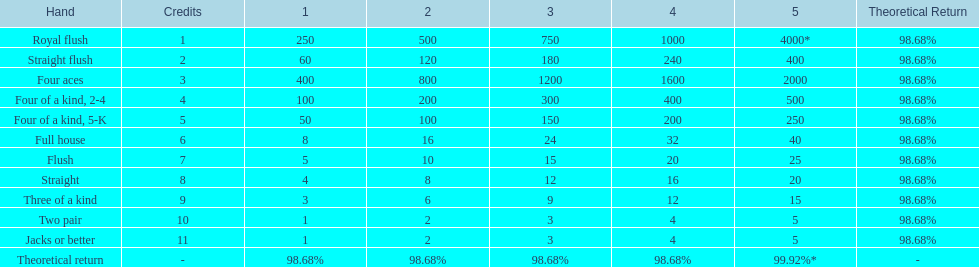How many credits do you have to spend to get at least 2000 in payout if you had four aces? 5 credits. 